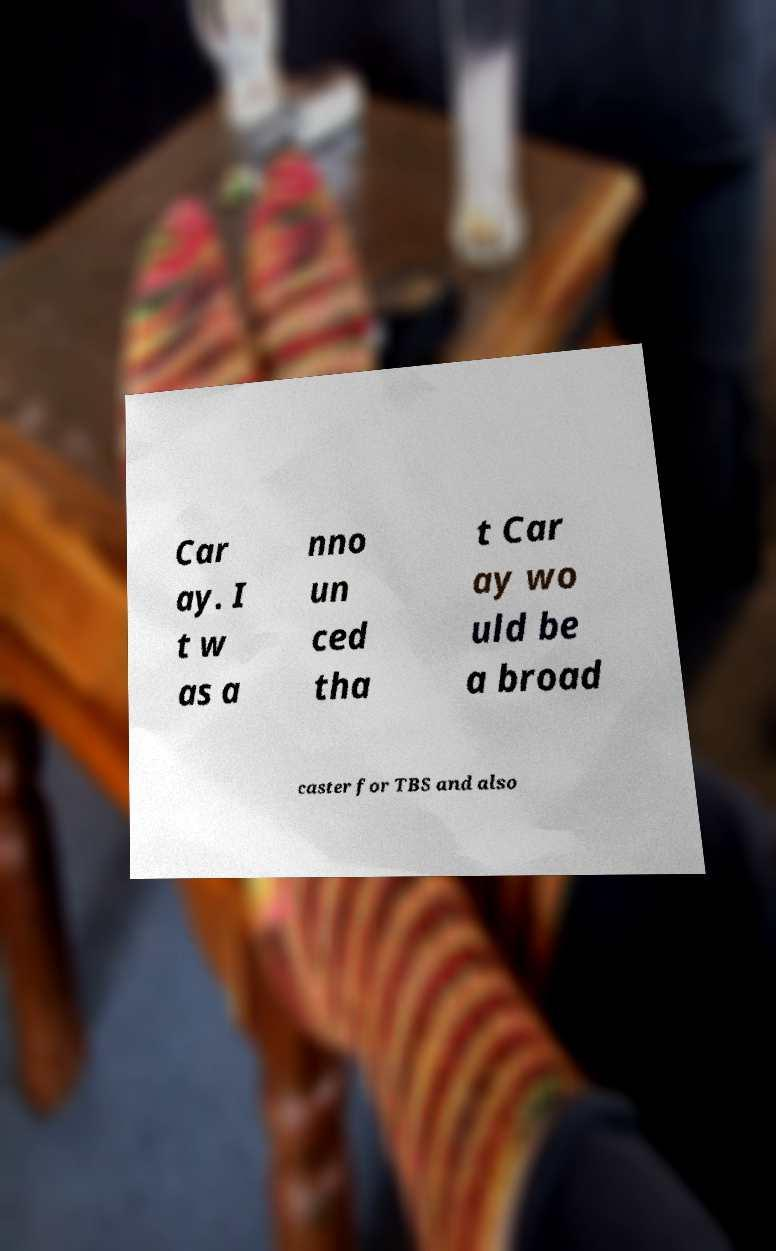Please read and relay the text visible in this image. What does it say? Car ay. I t w as a nno un ced tha t Car ay wo uld be a broad caster for TBS and also 